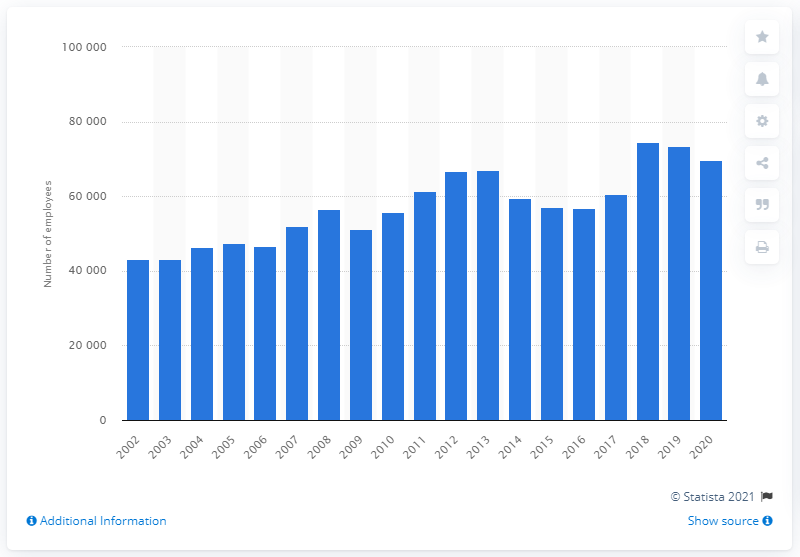List a handful of essential elements in this visual. In 2020, John Deere employed 69,634 people. In the previous year, John Deere had approximately 73,489 employees. 